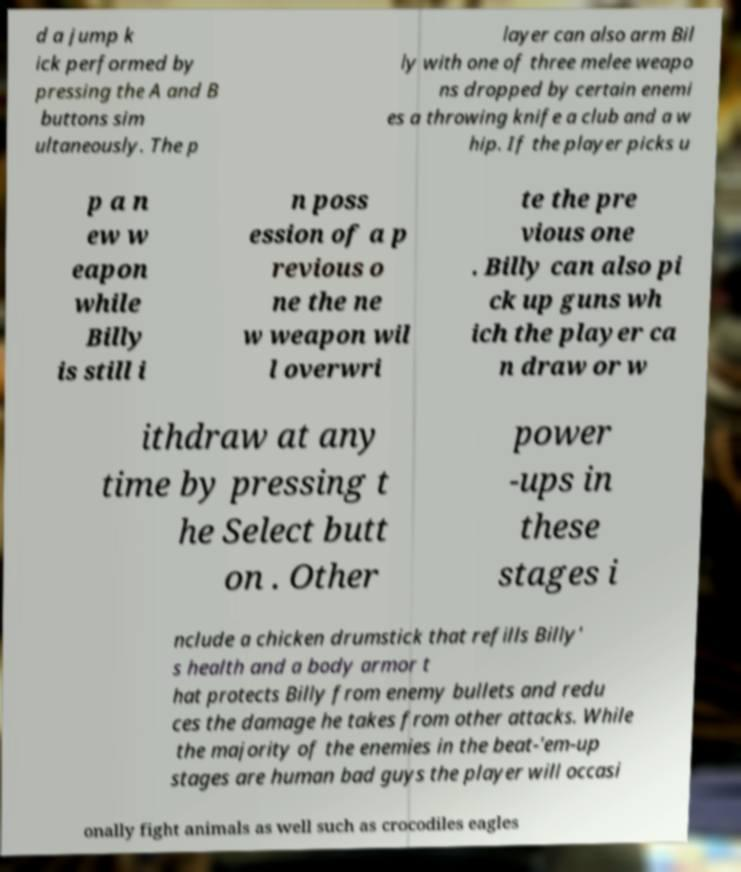There's text embedded in this image that I need extracted. Can you transcribe it verbatim? d a jump k ick performed by pressing the A and B buttons sim ultaneously. The p layer can also arm Bil ly with one of three melee weapo ns dropped by certain enemi es a throwing knife a club and a w hip. If the player picks u p a n ew w eapon while Billy is still i n poss ession of a p revious o ne the ne w weapon wil l overwri te the pre vious one . Billy can also pi ck up guns wh ich the player ca n draw or w ithdraw at any time by pressing t he Select butt on . Other power -ups in these stages i nclude a chicken drumstick that refills Billy' s health and a body armor t hat protects Billy from enemy bullets and redu ces the damage he takes from other attacks. While the majority of the enemies in the beat-'em-up stages are human bad guys the player will occasi onally fight animals as well such as crocodiles eagles 